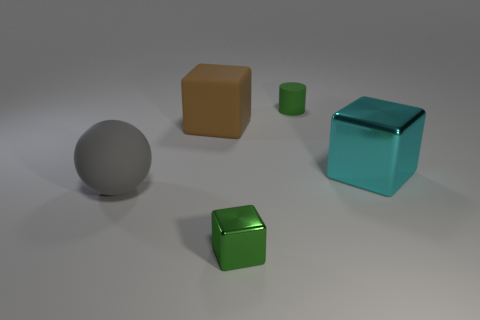Are there any other things that are the same shape as the green matte thing?
Keep it short and to the point. No. What is the shape of the gray object?
Provide a short and direct response. Sphere. Do the small object that is in front of the large ball and the thing left of the big rubber block have the same material?
Your answer should be compact. No. What number of large metallic blocks are the same color as the small metal object?
Your answer should be compact. 0. There is a big object that is right of the large rubber ball and left of the large metallic thing; what is its shape?
Your response must be concise. Cube. The object that is both to the left of the tiny green metallic thing and right of the gray thing is what color?
Your answer should be very brief. Brown. Is the number of cylinders that are in front of the big ball greater than the number of small green metal blocks that are to the right of the small green metallic thing?
Offer a terse response. No. What color is the metallic thing that is in front of the big gray rubber ball?
Offer a very short reply. Green. There is a green thing in front of the large brown cube; is its shape the same as the big object on the right side of the big matte cube?
Ensure brevity in your answer.  Yes. Is there a brown matte cube of the same size as the gray thing?
Provide a short and direct response. Yes. 